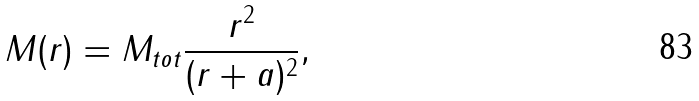Convert formula to latex. <formula><loc_0><loc_0><loc_500><loc_500>M ( r ) = M _ { t o t } \frac { r ^ { 2 } } { ( r + a ) ^ { 2 } } ,</formula> 